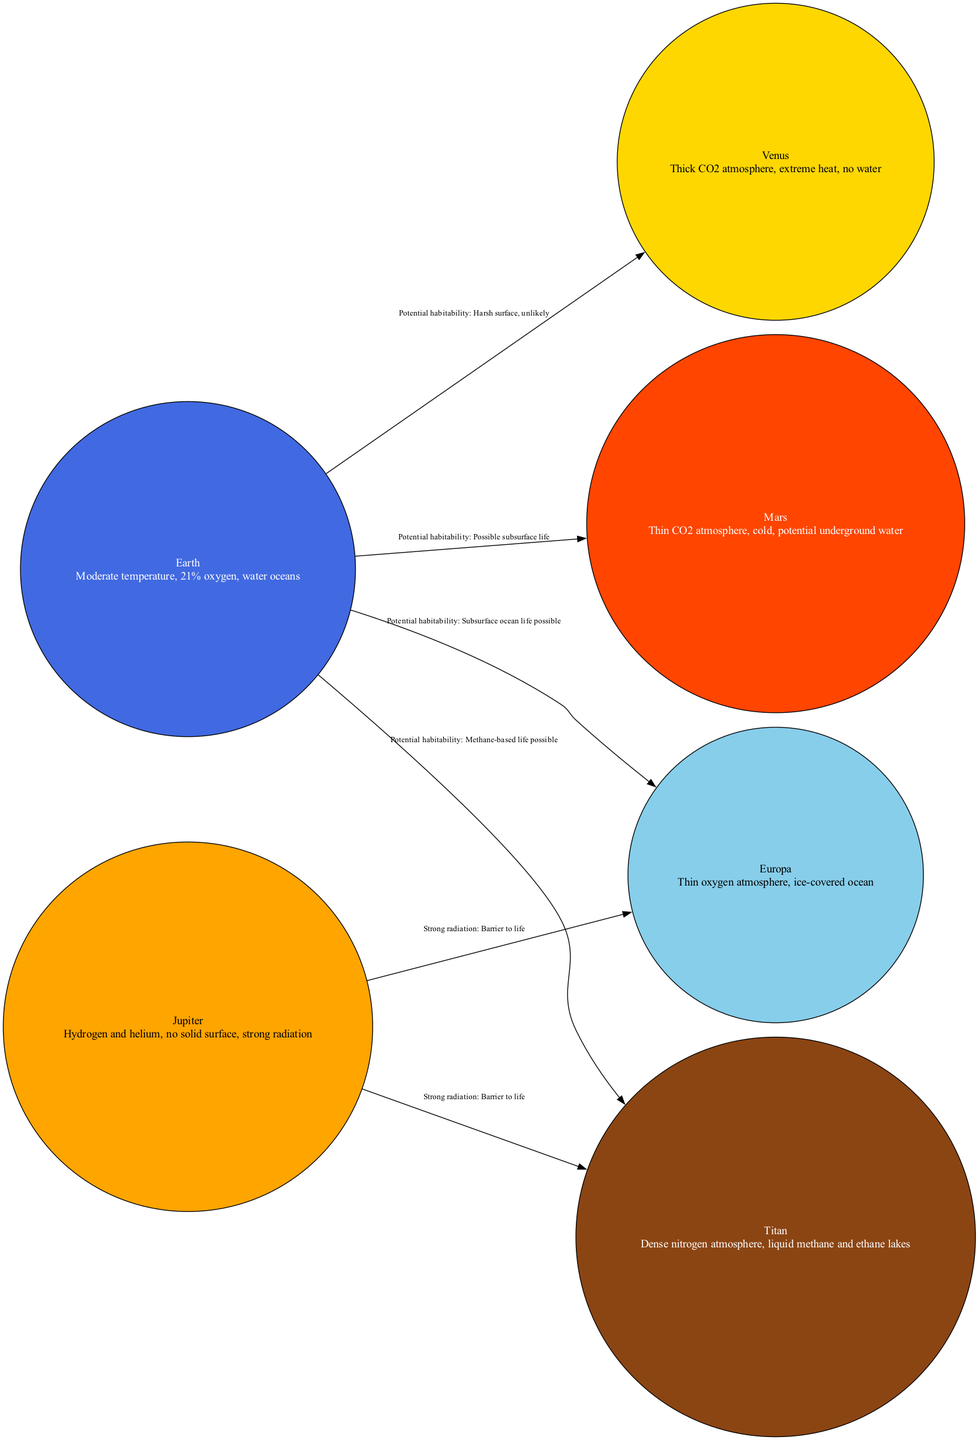What is the total number of nodes in the diagram? The diagram lists six different nodes representing celestial bodies and their atmospheric characteristics. These nodes are Earth, Mars, Venus, Jupiter, Titan, and Europa. By counting them, we confirm there are six nodes.
Answer: 6 Which planet has a thin CO2 atmosphere? The diagram indicates that Mars is described as having a "thin CO2 atmosphere." This description helps identify Mars as the correct answer.
Answer: Mars How many potential habitability connections are shown for Earth? By examining the edges connected to Earth, we find that there are four connections: to Mars, Venus, Titan, and Europa. This indicates that Earth has four potential habitability connections.
Answer: 4 What is the main barrier to life for both Titan and Europa according to the diagram? The diagram shows that the edge from Jupiter to both Titan and Europa states "Strong radiation: Barrier to life." This indicates that strong radiation is a common barrier to life for these moons.
Answer: Strong radiation Which body is described as having a subsurface ocean? The diagram highlights Europa as having an "ice-covered ocean," suggesting the presence of a subsurface ocean. This description distinctly identifies Europa as the answer.
Answer: Europa What type of atmosphere does Venus have? The diagram clearly classifies Venus as having a "thick CO2 atmosphere." This succinctly defines the atmosphere type for Venus.
Answer: Thick CO2 atmosphere Is there potential for underground water on Mars? The description for Mars in the diagram mentions "potential underground water," suggesting this possibility. Thus, the answer to the question is affirmatively supported by the text.
Answer: Yes What potential form of life is suggested for Titan? According to the diagram, the potential habitability connection from Earth to Titan mentions "Methane-based life possible." This indicates the specific potential form of life for Titan.
Answer: Methane-based life possible Please name the atmosphere of Europa. The diagram describes Europa as having a "thin oxygen atmosphere." This specific phrase directly identifies Europa's atmosphere.
Answer: Thin oxygen atmosphere 